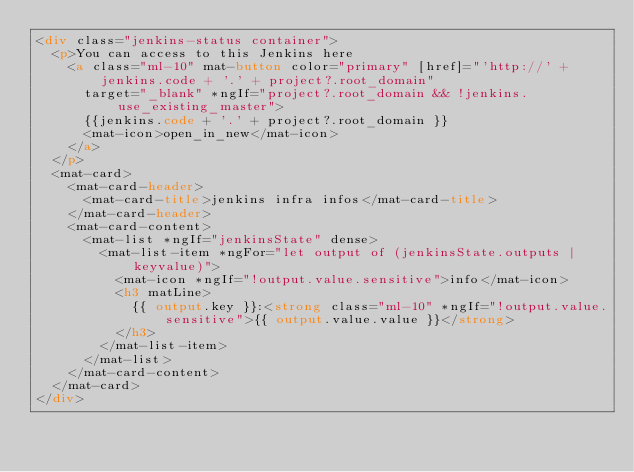<code> <loc_0><loc_0><loc_500><loc_500><_HTML_><div class="jenkins-status container">
  <p>You can access to this Jenkins here
    <a class="ml-10" mat-button color="primary" [href]="'http://' + jenkins.code + '.' + project?.root_domain"
      target="_blank" *ngIf="project?.root_domain && !jenkins.use_existing_master">
      {{jenkins.code + '.' + project?.root_domain }}
      <mat-icon>open_in_new</mat-icon>
    </a>
  </p>
  <mat-card>
    <mat-card-header>
      <mat-card-title>jenkins infra infos</mat-card-title>
    </mat-card-header>
    <mat-card-content>
      <mat-list *ngIf="jenkinsState" dense>
        <mat-list-item *ngFor="let output of (jenkinsState.outputs | keyvalue)">
          <mat-icon *ngIf="!output.value.sensitive">info</mat-icon>
          <h3 matLine>
            {{ output.key }}:<strong class="ml-10" *ngIf="!output.value.sensitive">{{ output.value.value }}</strong>
          </h3>
        </mat-list-item>
      </mat-list>
    </mat-card-content>
  </mat-card>
</div></code> 